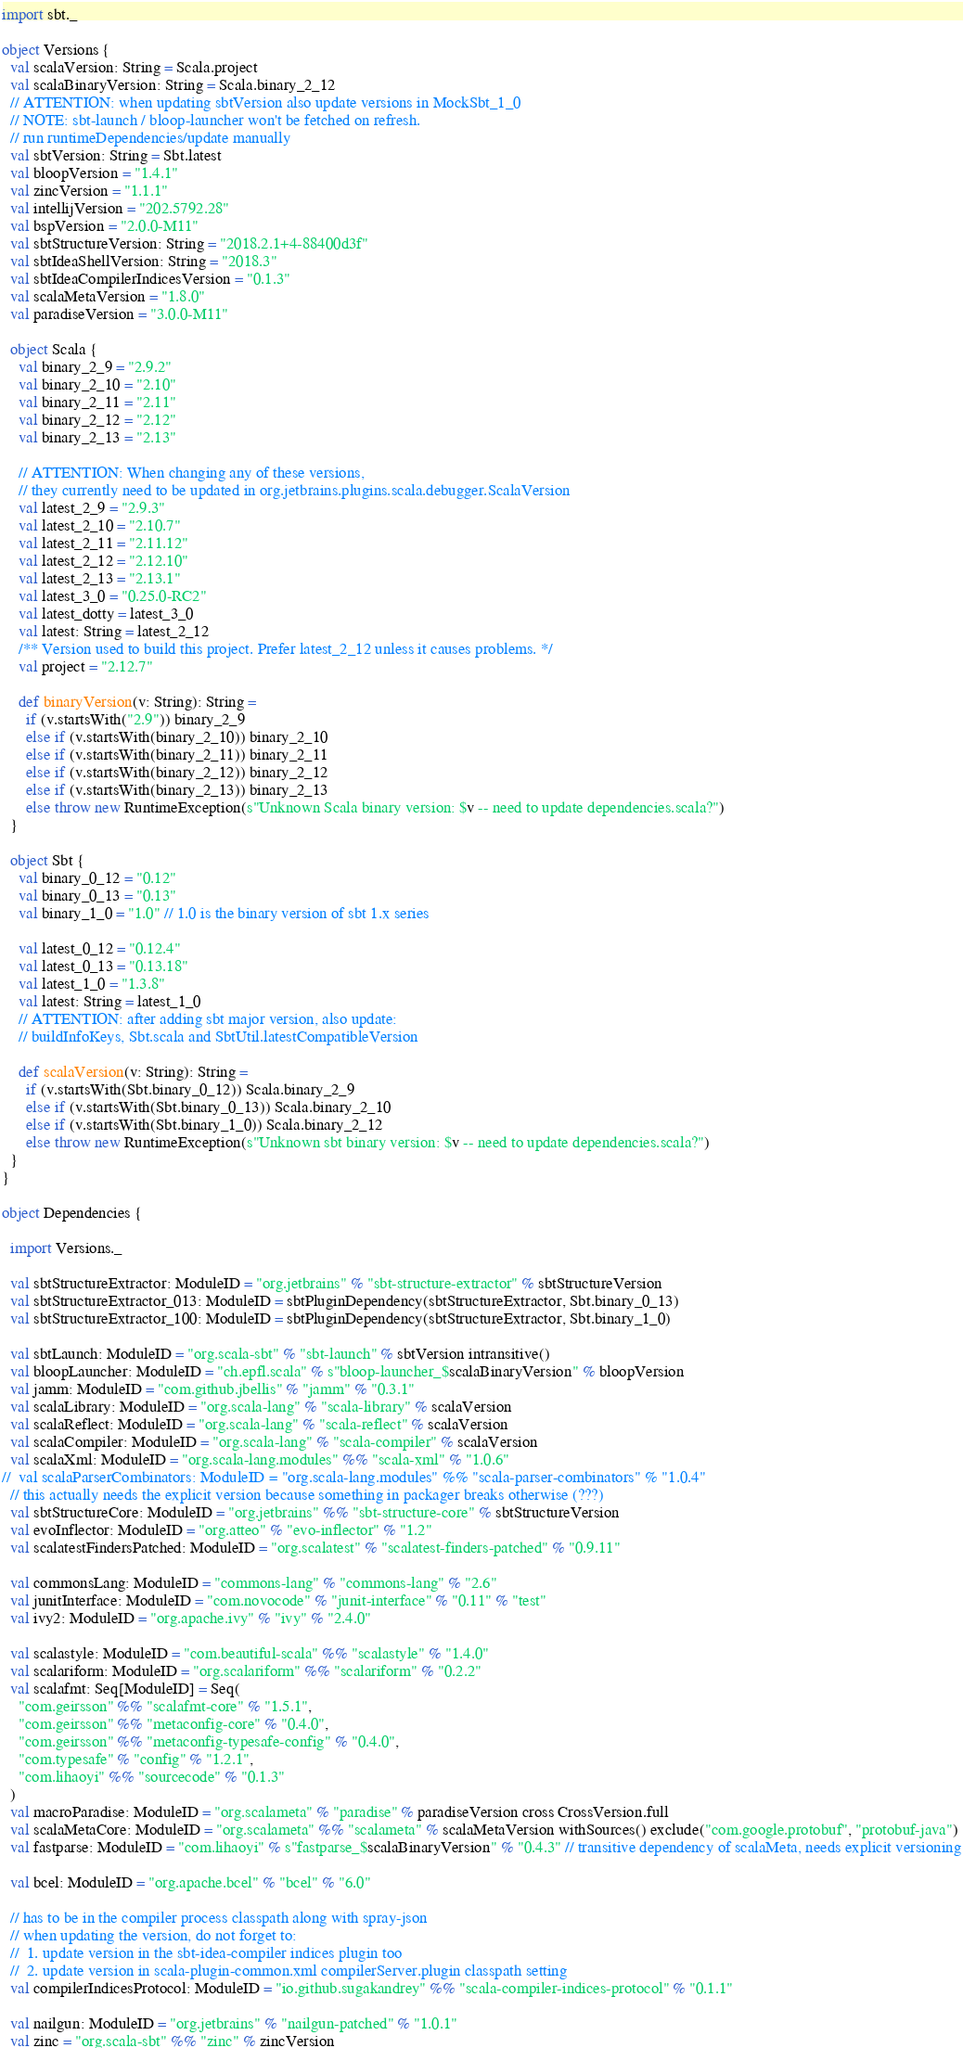<code> <loc_0><loc_0><loc_500><loc_500><_Scala_>import sbt._

object Versions {
  val scalaVersion: String = Scala.project
  val scalaBinaryVersion: String = Scala.binary_2_12
  // ATTENTION: when updating sbtVersion also update versions in MockSbt_1_0
  // NOTE: sbt-launch / bloop-launcher won't be fetched on refresh.
  // run runtimeDependencies/update manually
  val sbtVersion: String = Sbt.latest
  val bloopVersion = "1.4.1"
  val zincVersion = "1.1.1"
  val intellijVersion = "202.5792.28"
  val bspVersion = "2.0.0-M11"
  val sbtStructureVersion: String = "2018.2.1+4-88400d3f"
  val sbtIdeaShellVersion: String = "2018.3"
  val sbtIdeaCompilerIndicesVersion = "0.1.3"
  val scalaMetaVersion = "1.8.0"
  val paradiseVersion = "3.0.0-M11"

  object Scala {
    val binary_2_9 = "2.9.2"
    val binary_2_10 = "2.10"
    val binary_2_11 = "2.11"
    val binary_2_12 = "2.12"
    val binary_2_13 = "2.13"

    // ATTENTION: When changing any of these versions,
    // they currently need to be updated in org.jetbrains.plugins.scala.debugger.ScalaVersion
    val latest_2_9 = "2.9.3"
    val latest_2_10 = "2.10.7"
    val latest_2_11 = "2.11.12"
    val latest_2_12 = "2.12.10"
    val latest_2_13 = "2.13.1"
    val latest_3_0 = "0.25.0-RC2"
    val latest_dotty = latest_3_0
    val latest: String = latest_2_12
    /** Version used to build this project. Prefer latest_2_12 unless it causes problems. */
    val project = "2.12.7"

    def binaryVersion(v: String): String =
      if (v.startsWith("2.9")) binary_2_9
      else if (v.startsWith(binary_2_10)) binary_2_10
      else if (v.startsWith(binary_2_11)) binary_2_11
      else if (v.startsWith(binary_2_12)) binary_2_12
      else if (v.startsWith(binary_2_13)) binary_2_13
      else throw new RuntimeException(s"Unknown Scala binary version: $v -- need to update dependencies.scala?")
  }

  object Sbt {
    val binary_0_12 = "0.12"
    val binary_0_13 = "0.13"
    val binary_1_0 = "1.0" // 1.0 is the binary version of sbt 1.x series

    val latest_0_12 = "0.12.4"
    val latest_0_13 = "0.13.18"
    val latest_1_0 = "1.3.8"
    val latest: String = latest_1_0
    // ATTENTION: after adding sbt major version, also update:
    // buildInfoKeys, Sbt.scala and SbtUtil.latestCompatibleVersion

    def scalaVersion(v: String): String =
      if (v.startsWith(Sbt.binary_0_12)) Scala.binary_2_9
      else if (v.startsWith(Sbt.binary_0_13)) Scala.binary_2_10
      else if (v.startsWith(Sbt.binary_1_0)) Scala.binary_2_12
      else throw new RuntimeException(s"Unknown sbt binary version: $v -- need to update dependencies.scala?")
  }
}

object Dependencies {

  import Versions._

  val sbtStructureExtractor: ModuleID = "org.jetbrains" % "sbt-structure-extractor" % sbtStructureVersion
  val sbtStructureExtractor_013: ModuleID = sbtPluginDependency(sbtStructureExtractor, Sbt.binary_0_13)
  val sbtStructureExtractor_100: ModuleID = sbtPluginDependency(sbtStructureExtractor, Sbt.binary_1_0)

  val sbtLaunch: ModuleID = "org.scala-sbt" % "sbt-launch" % sbtVersion intransitive()
  val bloopLauncher: ModuleID = "ch.epfl.scala" % s"bloop-launcher_$scalaBinaryVersion" % bloopVersion
  val jamm: ModuleID = "com.github.jbellis" % "jamm" % "0.3.1"
  val scalaLibrary: ModuleID = "org.scala-lang" % "scala-library" % scalaVersion
  val scalaReflect: ModuleID = "org.scala-lang" % "scala-reflect" % scalaVersion
  val scalaCompiler: ModuleID = "org.scala-lang" % "scala-compiler" % scalaVersion
  val scalaXml: ModuleID = "org.scala-lang.modules" %% "scala-xml" % "1.0.6"
//  val scalaParserCombinators: ModuleID = "org.scala-lang.modules" %% "scala-parser-combinators" % "1.0.4"
  // this actually needs the explicit version because something in packager breaks otherwise (???)
  val sbtStructureCore: ModuleID = "org.jetbrains" %% "sbt-structure-core" % sbtStructureVersion
  val evoInflector: ModuleID = "org.atteo" % "evo-inflector" % "1.2"
  val scalatestFindersPatched: ModuleID = "org.scalatest" % "scalatest-finders-patched" % "0.9.11"

  val commonsLang: ModuleID = "commons-lang" % "commons-lang" % "2.6"
  val junitInterface: ModuleID = "com.novocode" % "junit-interface" % "0.11" % "test"
  val ivy2: ModuleID = "org.apache.ivy" % "ivy" % "2.4.0"

  val scalastyle: ModuleID = "com.beautiful-scala" %% "scalastyle" % "1.4.0"
  val scalariform: ModuleID = "org.scalariform" %% "scalariform" % "0.2.2"
  val scalafmt: Seq[ModuleID] = Seq(
    "com.geirsson" %% "scalafmt-core" % "1.5.1",
    "com.geirsson" %% "metaconfig-core" % "0.4.0",
    "com.geirsson" %% "metaconfig-typesafe-config" % "0.4.0",
    "com.typesafe" % "config" % "1.2.1",
    "com.lihaoyi" %% "sourcecode" % "0.1.3"
  )
  val macroParadise: ModuleID = "org.scalameta" % "paradise" % paradiseVersion cross CrossVersion.full
  val scalaMetaCore: ModuleID = "org.scalameta" %% "scalameta" % scalaMetaVersion withSources() exclude("com.google.protobuf", "protobuf-java")
  val fastparse: ModuleID = "com.lihaoyi" % s"fastparse_$scalaBinaryVersion" % "0.4.3" // transitive dependency of scalaMeta, needs explicit versioning

  val bcel: ModuleID = "org.apache.bcel" % "bcel" % "6.0"

  // has to be in the compiler process classpath along with spray-json
  // when updating the version, do not forget to:
  //  1. update version in the sbt-idea-compiler indices plugin too
  //  2. update version in scala-plugin-common.xml compilerServer.plugin classpath setting
  val compilerIndicesProtocol: ModuleID = "io.github.sugakandrey" %% "scala-compiler-indices-protocol" % "0.1.1"

  val nailgun: ModuleID = "org.jetbrains" % "nailgun-patched" % "1.0.1"
  val zinc = "org.scala-sbt" %% "zinc" % zincVersion</code> 